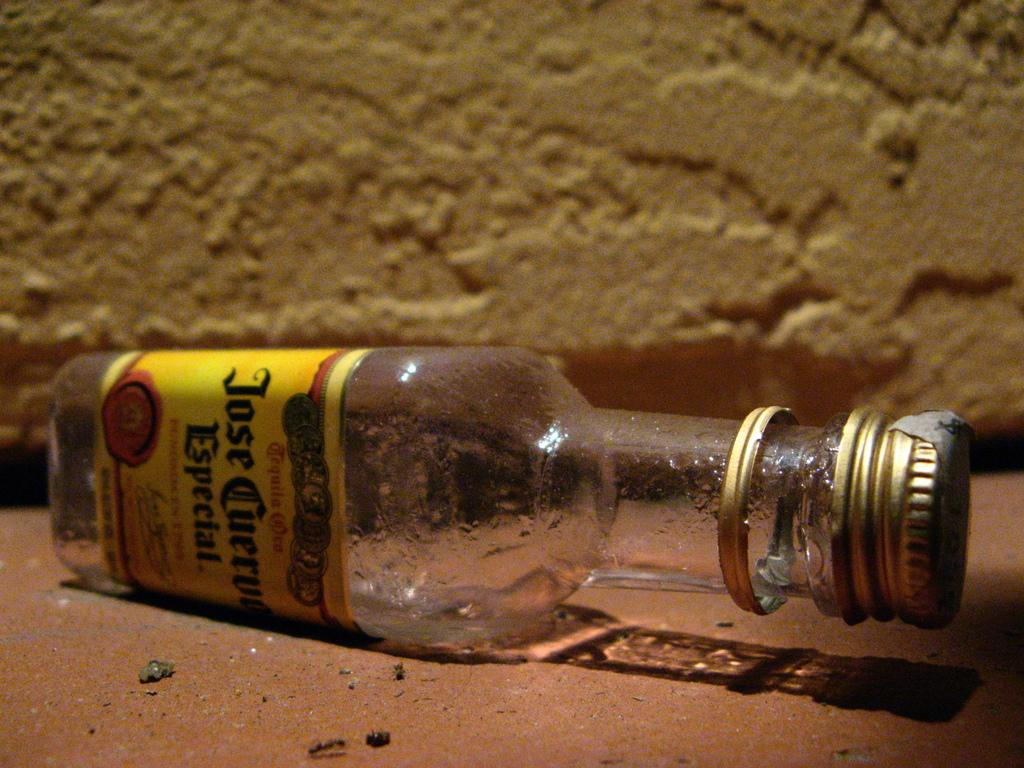Provide a one-sentence caption for the provided image. An empty bottle of Jose Cuervo lies sideways on the ground. 